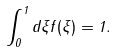Convert formula to latex. <formula><loc_0><loc_0><loc_500><loc_500>\int _ { 0 } ^ { 1 } d \xi f ( \xi ) = 1 .</formula> 